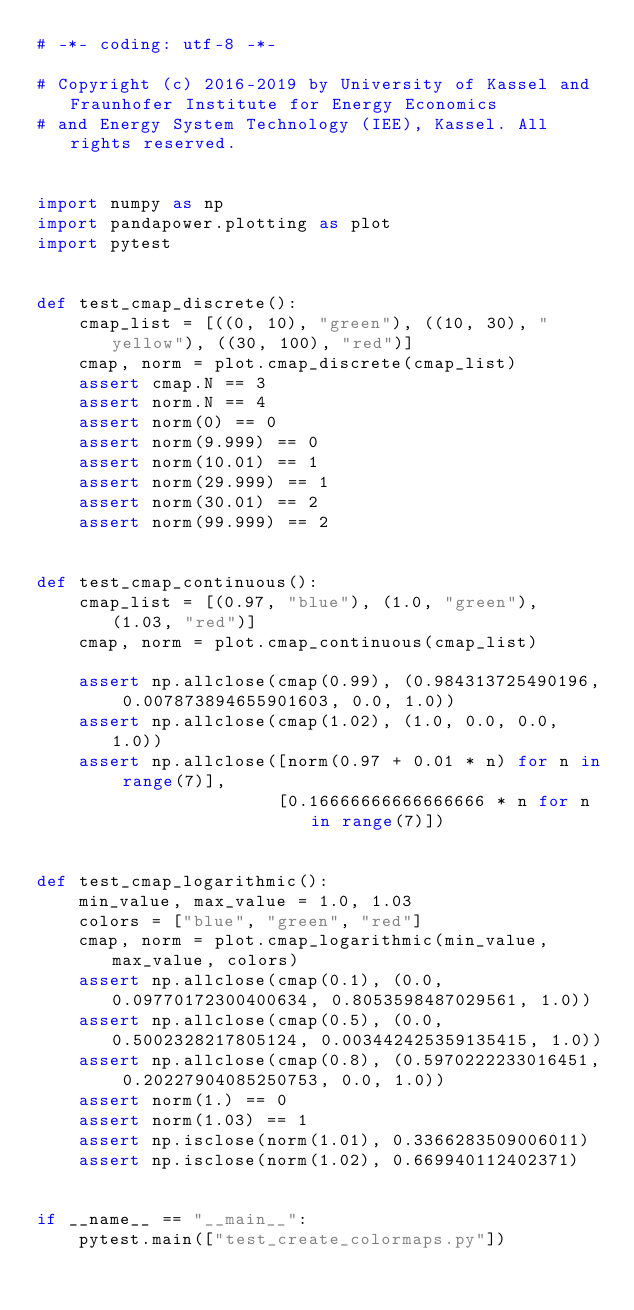Convert code to text. <code><loc_0><loc_0><loc_500><loc_500><_Python_># -*- coding: utf-8 -*-

# Copyright (c) 2016-2019 by University of Kassel and Fraunhofer Institute for Energy Economics
# and Energy System Technology (IEE), Kassel. All rights reserved.


import numpy as np
import pandapower.plotting as plot
import pytest


def test_cmap_discrete():
    cmap_list = [((0, 10), "green"), ((10, 30), "yellow"), ((30, 100), "red")]
    cmap, norm = plot.cmap_discrete(cmap_list)
    assert cmap.N == 3
    assert norm.N == 4
    assert norm(0) == 0
    assert norm(9.999) == 0
    assert norm(10.01) == 1
    assert norm(29.999) == 1
    assert norm(30.01) == 2
    assert norm(99.999) == 2


def test_cmap_continuous():
    cmap_list = [(0.97, "blue"), (1.0, "green"), (1.03, "red")]
    cmap, norm = plot.cmap_continuous(cmap_list)

    assert np.allclose(cmap(0.99), (0.984313725490196, 0.007873894655901603, 0.0, 1.0))
    assert np.allclose(cmap(1.02), (1.0, 0.0, 0.0, 1.0))
    assert np.allclose([norm(0.97 + 0.01 * n) for n in range(7)],
                       [0.16666666666666666 * n for n in range(7)])


def test_cmap_logarithmic():
    min_value, max_value = 1.0, 1.03
    colors = ["blue", "green", "red"]
    cmap, norm = plot.cmap_logarithmic(min_value, max_value, colors)
    assert np.allclose(cmap(0.1), (0.0, 0.09770172300400634, 0.8053598487029561, 1.0))
    assert np.allclose(cmap(0.5), (0.0, 0.5002328217805124, 0.003442425359135415, 1.0))
    assert np.allclose(cmap(0.8), (0.5970222233016451, 0.20227904085250753, 0.0, 1.0))
    assert norm(1.) == 0
    assert norm(1.03) == 1
    assert np.isclose(norm(1.01), 0.3366283509006011)
    assert np.isclose(norm(1.02), 0.669940112402371)


if __name__ == "__main__":
    pytest.main(["test_create_colormaps.py"])
</code> 